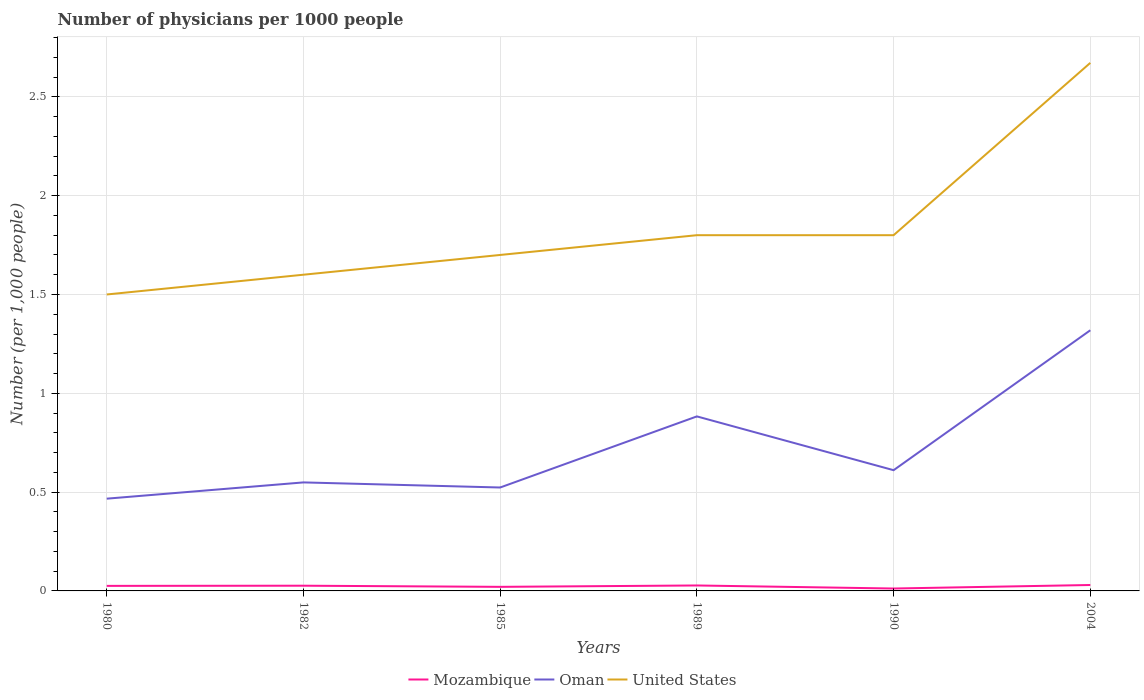How many different coloured lines are there?
Offer a terse response. 3. Does the line corresponding to Oman intersect with the line corresponding to United States?
Your response must be concise. No. Is the number of lines equal to the number of legend labels?
Provide a succinct answer. Yes. Across all years, what is the maximum number of physicians in Mozambique?
Your answer should be very brief. 0.01. What is the total number of physicians in United States in the graph?
Provide a succinct answer. -0.2. What is the difference between the highest and the second highest number of physicians in United States?
Offer a very short reply. 1.17. What is the difference between the highest and the lowest number of physicians in Oman?
Your response must be concise. 2. How many years are there in the graph?
Provide a succinct answer. 6. What is the difference between two consecutive major ticks on the Y-axis?
Your response must be concise. 0.5. Are the values on the major ticks of Y-axis written in scientific E-notation?
Your answer should be very brief. No. Does the graph contain grids?
Keep it short and to the point. Yes. Where does the legend appear in the graph?
Your answer should be very brief. Bottom center. How many legend labels are there?
Ensure brevity in your answer.  3. What is the title of the graph?
Your answer should be compact. Number of physicians per 1000 people. What is the label or title of the Y-axis?
Provide a short and direct response. Number (per 1,0 people). What is the Number (per 1,000 people) in Mozambique in 1980?
Offer a very short reply. 0.03. What is the Number (per 1,000 people) of Oman in 1980?
Your answer should be very brief. 0.47. What is the Number (per 1,000 people) of Mozambique in 1982?
Your answer should be very brief. 0.03. What is the Number (per 1,000 people) of Oman in 1982?
Your answer should be very brief. 0.55. What is the Number (per 1,000 people) in United States in 1982?
Your response must be concise. 1.6. What is the Number (per 1,000 people) of Mozambique in 1985?
Offer a very short reply. 0.02. What is the Number (per 1,000 people) of Oman in 1985?
Offer a very short reply. 0.52. What is the Number (per 1,000 people) in United States in 1985?
Keep it short and to the point. 1.7. What is the Number (per 1,000 people) of Mozambique in 1989?
Your answer should be very brief. 0.03. What is the Number (per 1,000 people) of Oman in 1989?
Give a very brief answer. 0.88. What is the Number (per 1,000 people) of Mozambique in 1990?
Provide a succinct answer. 0.01. What is the Number (per 1,000 people) of Oman in 1990?
Give a very brief answer. 0.61. What is the Number (per 1,000 people) in United States in 1990?
Provide a short and direct response. 1.8. What is the Number (per 1,000 people) in Mozambique in 2004?
Your answer should be very brief. 0.03. What is the Number (per 1,000 people) in Oman in 2004?
Your answer should be very brief. 1.32. What is the Number (per 1,000 people) of United States in 2004?
Your answer should be compact. 2.67. Across all years, what is the maximum Number (per 1,000 people) in Oman?
Provide a succinct answer. 1.32. Across all years, what is the maximum Number (per 1,000 people) in United States?
Provide a succinct answer. 2.67. Across all years, what is the minimum Number (per 1,000 people) in Mozambique?
Make the answer very short. 0.01. Across all years, what is the minimum Number (per 1,000 people) in Oman?
Ensure brevity in your answer.  0.47. What is the total Number (per 1,000 people) in Mozambique in the graph?
Your response must be concise. 0.14. What is the total Number (per 1,000 people) of Oman in the graph?
Your answer should be compact. 4.35. What is the total Number (per 1,000 people) in United States in the graph?
Offer a very short reply. 11.07. What is the difference between the Number (per 1,000 people) of Mozambique in 1980 and that in 1982?
Offer a very short reply. -0. What is the difference between the Number (per 1,000 people) in Oman in 1980 and that in 1982?
Your answer should be very brief. -0.08. What is the difference between the Number (per 1,000 people) in Mozambique in 1980 and that in 1985?
Your answer should be compact. 0. What is the difference between the Number (per 1,000 people) in Oman in 1980 and that in 1985?
Provide a short and direct response. -0.06. What is the difference between the Number (per 1,000 people) of United States in 1980 and that in 1985?
Keep it short and to the point. -0.2. What is the difference between the Number (per 1,000 people) of Mozambique in 1980 and that in 1989?
Your answer should be compact. -0. What is the difference between the Number (per 1,000 people) of Oman in 1980 and that in 1989?
Offer a terse response. -0.42. What is the difference between the Number (per 1,000 people) in Mozambique in 1980 and that in 1990?
Offer a terse response. 0.01. What is the difference between the Number (per 1,000 people) in Oman in 1980 and that in 1990?
Keep it short and to the point. -0.14. What is the difference between the Number (per 1,000 people) in Mozambique in 1980 and that in 2004?
Keep it short and to the point. -0. What is the difference between the Number (per 1,000 people) in Oman in 1980 and that in 2004?
Your answer should be very brief. -0.85. What is the difference between the Number (per 1,000 people) in United States in 1980 and that in 2004?
Provide a short and direct response. -1.17. What is the difference between the Number (per 1,000 people) of Mozambique in 1982 and that in 1985?
Your answer should be compact. 0.01. What is the difference between the Number (per 1,000 people) in Oman in 1982 and that in 1985?
Your answer should be compact. 0.03. What is the difference between the Number (per 1,000 people) in Mozambique in 1982 and that in 1989?
Give a very brief answer. -0. What is the difference between the Number (per 1,000 people) in Oman in 1982 and that in 1989?
Your answer should be compact. -0.33. What is the difference between the Number (per 1,000 people) of United States in 1982 and that in 1989?
Ensure brevity in your answer.  -0.2. What is the difference between the Number (per 1,000 people) of Mozambique in 1982 and that in 1990?
Provide a short and direct response. 0.01. What is the difference between the Number (per 1,000 people) of Oman in 1982 and that in 1990?
Offer a terse response. -0.06. What is the difference between the Number (per 1,000 people) of United States in 1982 and that in 1990?
Your answer should be very brief. -0.2. What is the difference between the Number (per 1,000 people) in Mozambique in 1982 and that in 2004?
Offer a terse response. -0. What is the difference between the Number (per 1,000 people) in Oman in 1982 and that in 2004?
Provide a succinct answer. -0.77. What is the difference between the Number (per 1,000 people) of United States in 1982 and that in 2004?
Make the answer very short. -1.07. What is the difference between the Number (per 1,000 people) of Mozambique in 1985 and that in 1989?
Give a very brief answer. -0.01. What is the difference between the Number (per 1,000 people) of Oman in 1985 and that in 1989?
Offer a very short reply. -0.36. What is the difference between the Number (per 1,000 people) in Mozambique in 1985 and that in 1990?
Offer a terse response. 0.01. What is the difference between the Number (per 1,000 people) in Oman in 1985 and that in 1990?
Offer a very short reply. -0.09. What is the difference between the Number (per 1,000 people) in Mozambique in 1985 and that in 2004?
Ensure brevity in your answer.  -0.01. What is the difference between the Number (per 1,000 people) of Oman in 1985 and that in 2004?
Your answer should be very brief. -0.8. What is the difference between the Number (per 1,000 people) of United States in 1985 and that in 2004?
Offer a terse response. -0.97. What is the difference between the Number (per 1,000 people) of Mozambique in 1989 and that in 1990?
Make the answer very short. 0.02. What is the difference between the Number (per 1,000 people) in Oman in 1989 and that in 1990?
Offer a terse response. 0.27. What is the difference between the Number (per 1,000 people) in United States in 1989 and that in 1990?
Your answer should be very brief. 0. What is the difference between the Number (per 1,000 people) in Mozambique in 1989 and that in 2004?
Your answer should be very brief. -0. What is the difference between the Number (per 1,000 people) in Oman in 1989 and that in 2004?
Provide a short and direct response. -0.44. What is the difference between the Number (per 1,000 people) in United States in 1989 and that in 2004?
Offer a very short reply. -0.87. What is the difference between the Number (per 1,000 people) of Mozambique in 1990 and that in 2004?
Your answer should be compact. -0.02. What is the difference between the Number (per 1,000 people) in Oman in 1990 and that in 2004?
Your response must be concise. -0.71. What is the difference between the Number (per 1,000 people) of United States in 1990 and that in 2004?
Offer a very short reply. -0.87. What is the difference between the Number (per 1,000 people) in Mozambique in 1980 and the Number (per 1,000 people) in Oman in 1982?
Give a very brief answer. -0.52. What is the difference between the Number (per 1,000 people) of Mozambique in 1980 and the Number (per 1,000 people) of United States in 1982?
Make the answer very short. -1.57. What is the difference between the Number (per 1,000 people) in Oman in 1980 and the Number (per 1,000 people) in United States in 1982?
Your response must be concise. -1.13. What is the difference between the Number (per 1,000 people) in Mozambique in 1980 and the Number (per 1,000 people) in Oman in 1985?
Offer a very short reply. -0.5. What is the difference between the Number (per 1,000 people) of Mozambique in 1980 and the Number (per 1,000 people) of United States in 1985?
Keep it short and to the point. -1.67. What is the difference between the Number (per 1,000 people) of Oman in 1980 and the Number (per 1,000 people) of United States in 1985?
Offer a very short reply. -1.23. What is the difference between the Number (per 1,000 people) in Mozambique in 1980 and the Number (per 1,000 people) in Oman in 1989?
Your answer should be very brief. -0.86. What is the difference between the Number (per 1,000 people) of Mozambique in 1980 and the Number (per 1,000 people) of United States in 1989?
Offer a terse response. -1.77. What is the difference between the Number (per 1,000 people) in Oman in 1980 and the Number (per 1,000 people) in United States in 1989?
Your answer should be very brief. -1.33. What is the difference between the Number (per 1,000 people) of Mozambique in 1980 and the Number (per 1,000 people) of Oman in 1990?
Offer a very short reply. -0.59. What is the difference between the Number (per 1,000 people) in Mozambique in 1980 and the Number (per 1,000 people) in United States in 1990?
Offer a terse response. -1.77. What is the difference between the Number (per 1,000 people) in Oman in 1980 and the Number (per 1,000 people) in United States in 1990?
Provide a succinct answer. -1.33. What is the difference between the Number (per 1,000 people) in Mozambique in 1980 and the Number (per 1,000 people) in Oman in 2004?
Provide a succinct answer. -1.29. What is the difference between the Number (per 1,000 people) of Mozambique in 1980 and the Number (per 1,000 people) of United States in 2004?
Keep it short and to the point. -2.65. What is the difference between the Number (per 1,000 people) in Oman in 1980 and the Number (per 1,000 people) in United States in 2004?
Provide a succinct answer. -2.21. What is the difference between the Number (per 1,000 people) in Mozambique in 1982 and the Number (per 1,000 people) in Oman in 1985?
Your answer should be very brief. -0.5. What is the difference between the Number (per 1,000 people) in Mozambique in 1982 and the Number (per 1,000 people) in United States in 1985?
Give a very brief answer. -1.67. What is the difference between the Number (per 1,000 people) of Oman in 1982 and the Number (per 1,000 people) of United States in 1985?
Ensure brevity in your answer.  -1.15. What is the difference between the Number (per 1,000 people) of Mozambique in 1982 and the Number (per 1,000 people) of Oman in 1989?
Provide a short and direct response. -0.86. What is the difference between the Number (per 1,000 people) of Mozambique in 1982 and the Number (per 1,000 people) of United States in 1989?
Keep it short and to the point. -1.77. What is the difference between the Number (per 1,000 people) of Oman in 1982 and the Number (per 1,000 people) of United States in 1989?
Keep it short and to the point. -1.25. What is the difference between the Number (per 1,000 people) of Mozambique in 1982 and the Number (per 1,000 people) of Oman in 1990?
Ensure brevity in your answer.  -0.58. What is the difference between the Number (per 1,000 people) of Mozambique in 1982 and the Number (per 1,000 people) of United States in 1990?
Your response must be concise. -1.77. What is the difference between the Number (per 1,000 people) of Oman in 1982 and the Number (per 1,000 people) of United States in 1990?
Offer a terse response. -1.25. What is the difference between the Number (per 1,000 people) in Mozambique in 1982 and the Number (per 1,000 people) in Oman in 2004?
Keep it short and to the point. -1.29. What is the difference between the Number (per 1,000 people) in Mozambique in 1982 and the Number (per 1,000 people) in United States in 2004?
Your answer should be very brief. -2.65. What is the difference between the Number (per 1,000 people) of Oman in 1982 and the Number (per 1,000 people) of United States in 2004?
Your answer should be compact. -2.12. What is the difference between the Number (per 1,000 people) of Mozambique in 1985 and the Number (per 1,000 people) of Oman in 1989?
Offer a terse response. -0.86. What is the difference between the Number (per 1,000 people) of Mozambique in 1985 and the Number (per 1,000 people) of United States in 1989?
Your answer should be compact. -1.78. What is the difference between the Number (per 1,000 people) of Oman in 1985 and the Number (per 1,000 people) of United States in 1989?
Your answer should be very brief. -1.28. What is the difference between the Number (per 1,000 people) in Mozambique in 1985 and the Number (per 1,000 people) in Oman in 1990?
Ensure brevity in your answer.  -0.59. What is the difference between the Number (per 1,000 people) of Mozambique in 1985 and the Number (per 1,000 people) of United States in 1990?
Offer a terse response. -1.78. What is the difference between the Number (per 1,000 people) of Oman in 1985 and the Number (per 1,000 people) of United States in 1990?
Ensure brevity in your answer.  -1.28. What is the difference between the Number (per 1,000 people) in Mozambique in 1985 and the Number (per 1,000 people) in Oman in 2004?
Your answer should be very brief. -1.3. What is the difference between the Number (per 1,000 people) in Mozambique in 1985 and the Number (per 1,000 people) in United States in 2004?
Provide a short and direct response. -2.65. What is the difference between the Number (per 1,000 people) in Oman in 1985 and the Number (per 1,000 people) in United States in 2004?
Keep it short and to the point. -2.15. What is the difference between the Number (per 1,000 people) in Mozambique in 1989 and the Number (per 1,000 people) in Oman in 1990?
Keep it short and to the point. -0.58. What is the difference between the Number (per 1,000 people) in Mozambique in 1989 and the Number (per 1,000 people) in United States in 1990?
Offer a terse response. -1.77. What is the difference between the Number (per 1,000 people) in Oman in 1989 and the Number (per 1,000 people) in United States in 1990?
Offer a very short reply. -0.92. What is the difference between the Number (per 1,000 people) in Mozambique in 1989 and the Number (per 1,000 people) in Oman in 2004?
Your answer should be very brief. -1.29. What is the difference between the Number (per 1,000 people) in Mozambique in 1989 and the Number (per 1,000 people) in United States in 2004?
Offer a terse response. -2.64. What is the difference between the Number (per 1,000 people) of Oman in 1989 and the Number (per 1,000 people) of United States in 2004?
Ensure brevity in your answer.  -1.79. What is the difference between the Number (per 1,000 people) in Mozambique in 1990 and the Number (per 1,000 people) in Oman in 2004?
Offer a very short reply. -1.31. What is the difference between the Number (per 1,000 people) of Mozambique in 1990 and the Number (per 1,000 people) of United States in 2004?
Give a very brief answer. -2.66. What is the difference between the Number (per 1,000 people) in Oman in 1990 and the Number (per 1,000 people) in United States in 2004?
Keep it short and to the point. -2.06. What is the average Number (per 1,000 people) in Mozambique per year?
Make the answer very short. 0.02. What is the average Number (per 1,000 people) of Oman per year?
Your response must be concise. 0.73. What is the average Number (per 1,000 people) in United States per year?
Provide a succinct answer. 1.85. In the year 1980, what is the difference between the Number (per 1,000 people) in Mozambique and Number (per 1,000 people) in Oman?
Make the answer very short. -0.44. In the year 1980, what is the difference between the Number (per 1,000 people) in Mozambique and Number (per 1,000 people) in United States?
Keep it short and to the point. -1.47. In the year 1980, what is the difference between the Number (per 1,000 people) in Oman and Number (per 1,000 people) in United States?
Ensure brevity in your answer.  -1.03. In the year 1982, what is the difference between the Number (per 1,000 people) in Mozambique and Number (per 1,000 people) in Oman?
Provide a short and direct response. -0.52. In the year 1982, what is the difference between the Number (per 1,000 people) in Mozambique and Number (per 1,000 people) in United States?
Give a very brief answer. -1.57. In the year 1982, what is the difference between the Number (per 1,000 people) of Oman and Number (per 1,000 people) of United States?
Provide a short and direct response. -1.05. In the year 1985, what is the difference between the Number (per 1,000 people) in Mozambique and Number (per 1,000 people) in Oman?
Make the answer very short. -0.5. In the year 1985, what is the difference between the Number (per 1,000 people) of Mozambique and Number (per 1,000 people) of United States?
Offer a very short reply. -1.68. In the year 1985, what is the difference between the Number (per 1,000 people) in Oman and Number (per 1,000 people) in United States?
Your answer should be compact. -1.18. In the year 1989, what is the difference between the Number (per 1,000 people) in Mozambique and Number (per 1,000 people) in Oman?
Your response must be concise. -0.86. In the year 1989, what is the difference between the Number (per 1,000 people) of Mozambique and Number (per 1,000 people) of United States?
Give a very brief answer. -1.77. In the year 1989, what is the difference between the Number (per 1,000 people) of Oman and Number (per 1,000 people) of United States?
Provide a short and direct response. -0.92. In the year 1990, what is the difference between the Number (per 1,000 people) of Mozambique and Number (per 1,000 people) of Oman?
Ensure brevity in your answer.  -0.6. In the year 1990, what is the difference between the Number (per 1,000 people) in Mozambique and Number (per 1,000 people) in United States?
Provide a succinct answer. -1.79. In the year 1990, what is the difference between the Number (per 1,000 people) of Oman and Number (per 1,000 people) of United States?
Ensure brevity in your answer.  -1.19. In the year 2004, what is the difference between the Number (per 1,000 people) of Mozambique and Number (per 1,000 people) of Oman?
Provide a succinct answer. -1.29. In the year 2004, what is the difference between the Number (per 1,000 people) of Mozambique and Number (per 1,000 people) of United States?
Ensure brevity in your answer.  -2.64. In the year 2004, what is the difference between the Number (per 1,000 people) of Oman and Number (per 1,000 people) of United States?
Your answer should be compact. -1.35. What is the ratio of the Number (per 1,000 people) of Mozambique in 1980 to that in 1982?
Keep it short and to the point. 0.97. What is the ratio of the Number (per 1,000 people) in Oman in 1980 to that in 1982?
Make the answer very short. 0.85. What is the ratio of the Number (per 1,000 people) in Mozambique in 1980 to that in 1985?
Provide a short and direct response. 1.24. What is the ratio of the Number (per 1,000 people) of Oman in 1980 to that in 1985?
Your response must be concise. 0.89. What is the ratio of the Number (per 1,000 people) of United States in 1980 to that in 1985?
Your answer should be compact. 0.88. What is the ratio of the Number (per 1,000 people) of Mozambique in 1980 to that in 1989?
Offer a very short reply. 0.92. What is the ratio of the Number (per 1,000 people) in Oman in 1980 to that in 1989?
Offer a terse response. 0.53. What is the ratio of the Number (per 1,000 people) in United States in 1980 to that in 1989?
Your response must be concise. 0.83. What is the ratio of the Number (per 1,000 people) of Mozambique in 1980 to that in 1990?
Offer a terse response. 2.09. What is the ratio of the Number (per 1,000 people) in Oman in 1980 to that in 1990?
Provide a short and direct response. 0.76. What is the ratio of the Number (per 1,000 people) of Oman in 1980 to that in 2004?
Your answer should be very brief. 0.35. What is the ratio of the Number (per 1,000 people) in United States in 1980 to that in 2004?
Your answer should be very brief. 0.56. What is the ratio of the Number (per 1,000 people) of Mozambique in 1982 to that in 1985?
Give a very brief answer. 1.28. What is the ratio of the Number (per 1,000 people) of Oman in 1982 to that in 1985?
Offer a terse response. 1.05. What is the ratio of the Number (per 1,000 people) of Mozambique in 1982 to that in 1989?
Offer a terse response. 0.96. What is the ratio of the Number (per 1,000 people) of Oman in 1982 to that in 1989?
Make the answer very short. 0.62. What is the ratio of the Number (per 1,000 people) of Mozambique in 1982 to that in 1990?
Make the answer very short. 2.17. What is the ratio of the Number (per 1,000 people) of Oman in 1982 to that in 1990?
Make the answer very short. 0.9. What is the ratio of the Number (per 1,000 people) of Mozambique in 1982 to that in 2004?
Provide a succinct answer. 0.88. What is the ratio of the Number (per 1,000 people) in Oman in 1982 to that in 2004?
Give a very brief answer. 0.42. What is the ratio of the Number (per 1,000 people) of United States in 1982 to that in 2004?
Provide a short and direct response. 0.6. What is the ratio of the Number (per 1,000 people) in Mozambique in 1985 to that in 1989?
Offer a very short reply. 0.75. What is the ratio of the Number (per 1,000 people) in Oman in 1985 to that in 1989?
Make the answer very short. 0.59. What is the ratio of the Number (per 1,000 people) of Mozambique in 1985 to that in 1990?
Give a very brief answer. 1.69. What is the ratio of the Number (per 1,000 people) in Oman in 1985 to that in 1990?
Your response must be concise. 0.86. What is the ratio of the Number (per 1,000 people) in Mozambique in 1985 to that in 2004?
Offer a very short reply. 0.69. What is the ratio of the Number (per 1,000 people) in Oman in 1985 to that in 2004?
Offer a very short reply. 0.4. What is the ratio of the Number (per 1,000 people) in United States in 1985 to that in 2004?
Offer a very short reply. 0.64. What is the ratio of the Number (per 1,000 people) in Mozambique in 1989 to that in 1990?
Make the answer very short. 2.27. What is the ratio of the Number (per 1,000 people) in Oman in 1989 to that in 1990?
Ensure brevity in your answer.  1.45. What is the ratio of the Number (per 1,000 people) of United States in 1989 to that in 1990?
Offer a terse response. 1. What is the ratio of the Number (per 1,000 people) in Mozambique in 1989 to that in 2004?
Keep it short and to the point. 0.92. What is the ratio of the Number (per 1,000 people) in Oman in 1989 to that in 2004?
Your answer should be compact. 0.67. What is the ratio of the Number (per 1,000 people) in United States in 1989 to that in 2004?
Your answer should be compact. 0.67. What is the ratio of the Number (per 1,000 people) of Mozambique in 1990 to that in 2004?
Your answer should be very brief. 0.41. What is the ratio of the Number (per 1,000 people) of Oman in 1990 to that in 2004?
Offer a terse response. 0.46. What is the ratio of the Number (per 1,000 people) in United States in 1990 to that in 2004?
Provide a succinct answer. 0.67. What is the difference between the highest and the second highest Number (per 1,000 people) of Mozambique?
Offer a very short reply. 0. What is the difference between the highest and the second highest Number (per 1,000 people) in Oman?
Keep it short and to the point. 0.44. What is the difference between the highest and the second highest Number (per 1,000 people) in United States?
Provide a succinct answer. 0.87. What is the difference between the highest and the lowest Number (per 1,000 people) in Mozambique?
Give a very brief answer. 0.02. What is the difference between the highest and the lowest Number (per 1,000 people) in Oman?
Provide a succinct answer. 0.85. What is the difference between the highest and the lowest Number (per 1,000 people) of United States?
Offer a terse response. 1.17. 